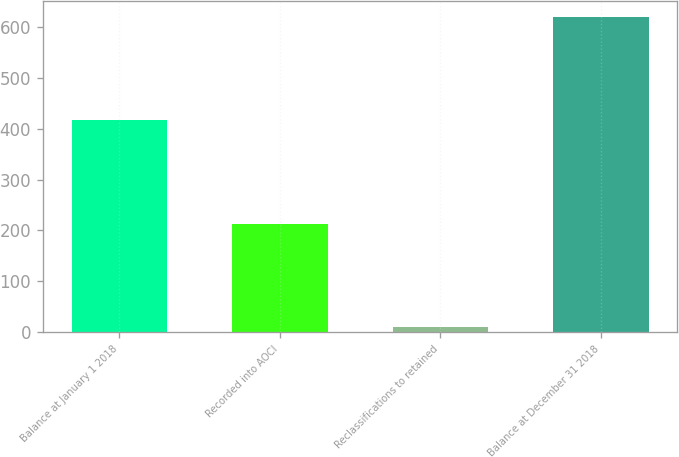<chart> <loc_0><loc_0><loc_500><loc_500><bar_chart><fcel>Balance at January 1 2018<fcel>Recorded into AOCI<fcel>Reclassifications to retained<fcel>Balance at December 31 2018<nl><fcel>417.4<fcel>213.3<fcel>10.3<fcel>620.4<nl></chart> 